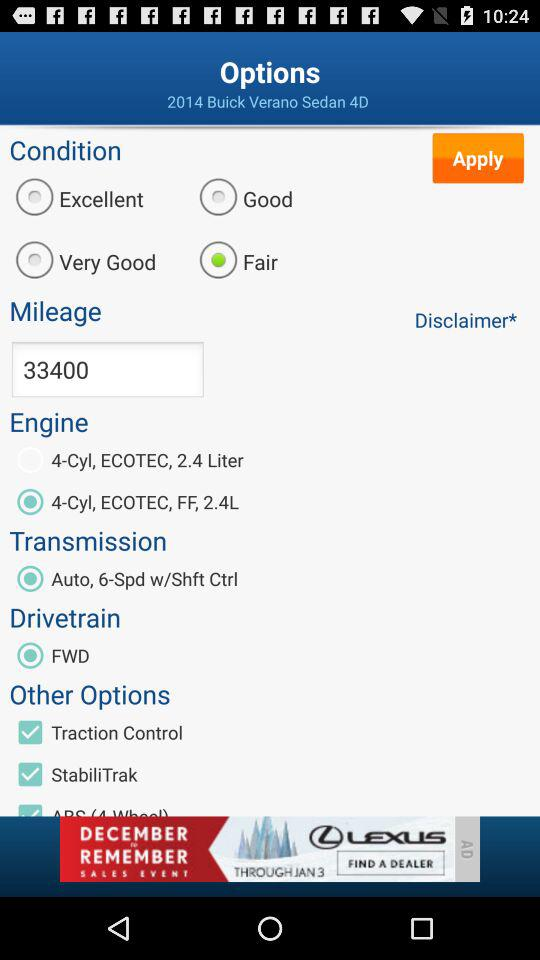What type of system is the "Drivetrain"? It is FWD type. 